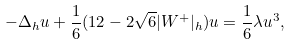<formula> <loc_0><loc_0><loc_500><loc_500>- \Delta _ { h } u + \frac { 1 } { 6 } ( 1 2 - 2 \sqrt { 6 } | W ^ { + } | _ { h } ) u = \frac { 1 } { 6 } \lambda u ^ { 3 } ,</formula> 